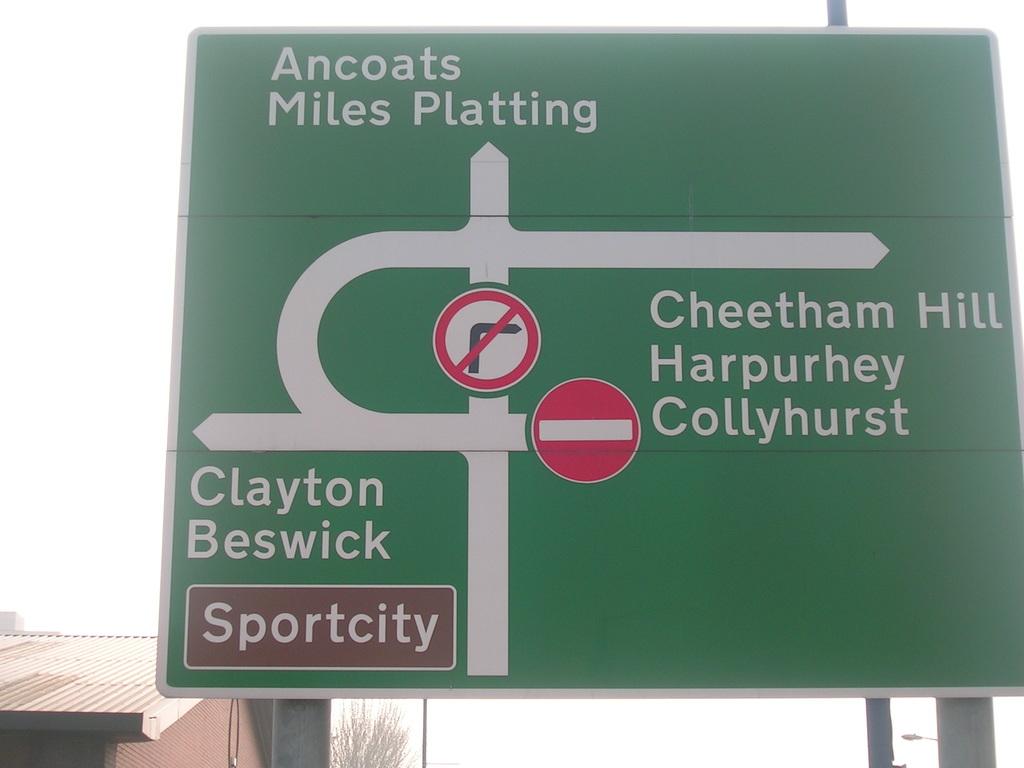If i make a left where will i go?
Ensure brevity in your answer.  Clayton beswick. What is the name of the hill?
Provide a succinct answer. Cheetham hill. 